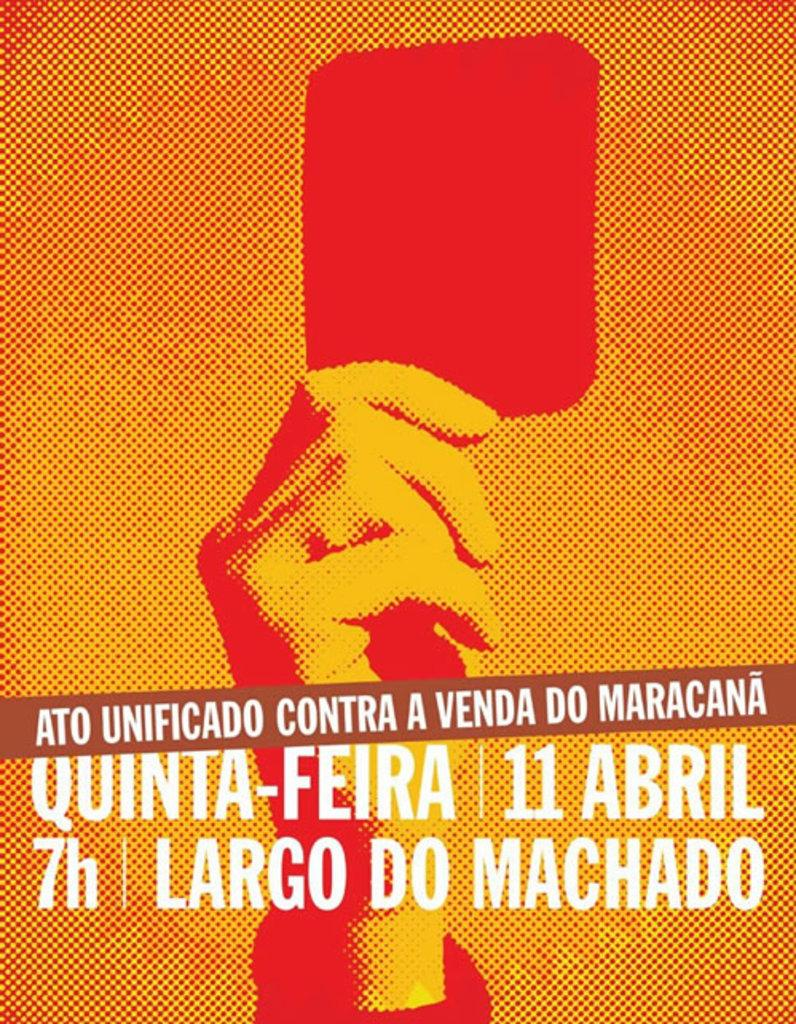<image>
Render a clear and concise summary of the photo. a poster that has the word Ato on it 